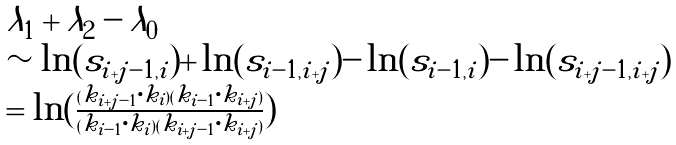Convert formula to latex. <formula><loc_0><loc_0><loc_500><loc_500>\begin{array} { l } \lambda _ { 1 } + \lambda _ { 2 } - \lambda _ { 0 } \\ \sim \ln ( s _ { i + j - 1 , i } ) + \ln ( s _ { i - 1 , i + j } ) - \ln ( s _ { i - 1 , i } ) - \ln ( s _ { i + j - 1 , i + j } ) \\ = \ln ( \frac { ( k _ { i + j - 1 } \cdot k _ { i } ) ( k _ { i - 1 } \cdot k _ { i + j } ) } { ( k _ { i - 1 } \cdot k _ { i } ) ( k _ { i + j - 1 } \cdot k _ { i + j } ) } ) \end{array}</formula> 